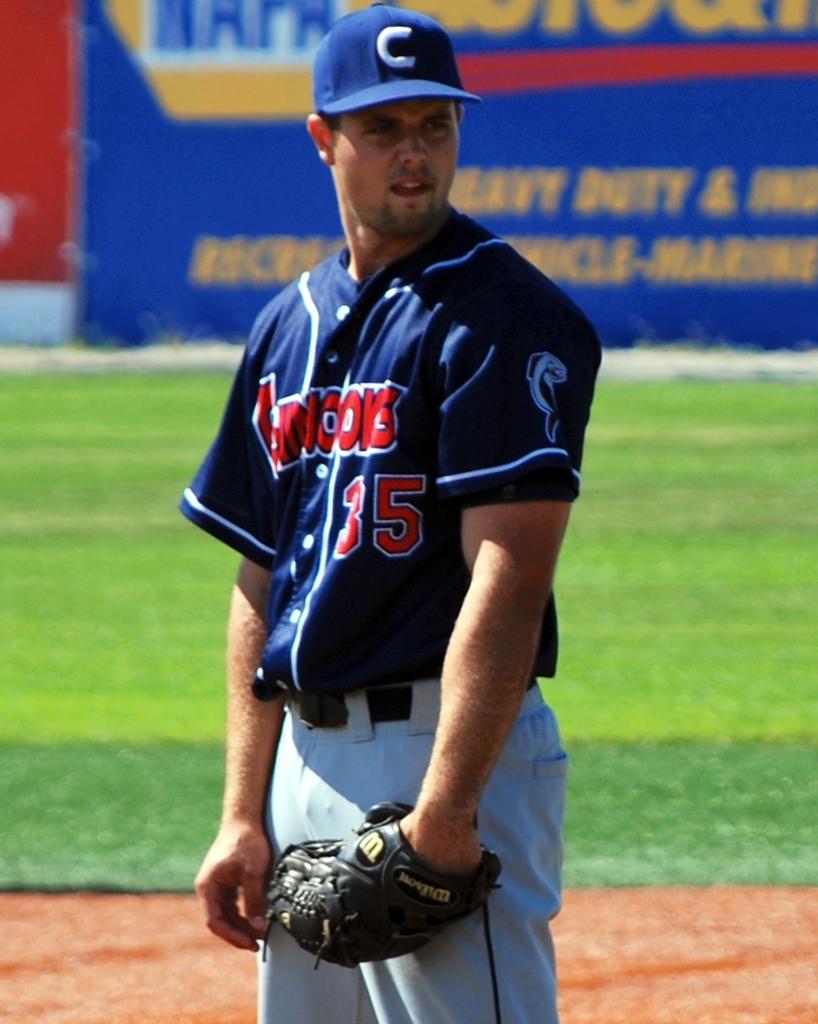What number is the baseball player?
Your answer should be compact. 35. 